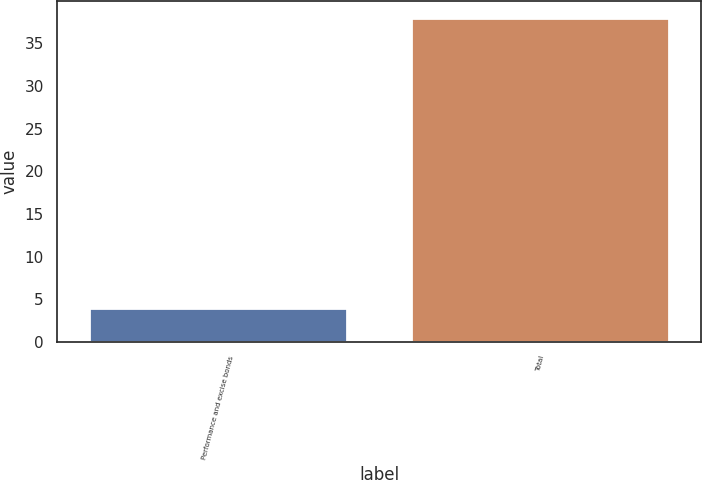Convert chart. <chart><loc_0><loc_0><loc_500><loc_500><bar_chart><fcel>Performance and excise bonds<fcel>Total<nl><fcel>4<fcel>38<nl></chart> 